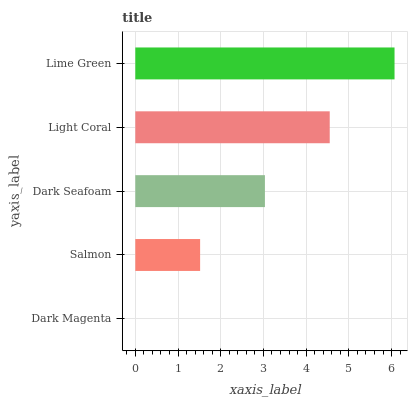Is Dark Magenta the minimum?
Answer yes or no. Yes. Is Lime Green the maximum?
Answer yes or no. Yes. Is Salmon the minimum?
Answer yes or no. No. Is Salmon the maximum?
Answer yes or no. No. Is Salmon greater than Dark Magenta?
Answer yes or no. Yes. Is Dark Magenta less than Salmon?
Answer yes or no. Yes. Is Dark Magenta greater than Salmon?
Answer yes or no. No. Is Salmon less than Dark Magenta?
Answer yes or no. No. Is Dark Seafoam the high median?
Answer yes or no. Yes. Is Dark Seafoam the low median?
Answer yes or no. Yes. Is Dark Magenta the high median?
Answer yes or no. No. Is Dark Magenta the low median?
Answer yes or no. No. 